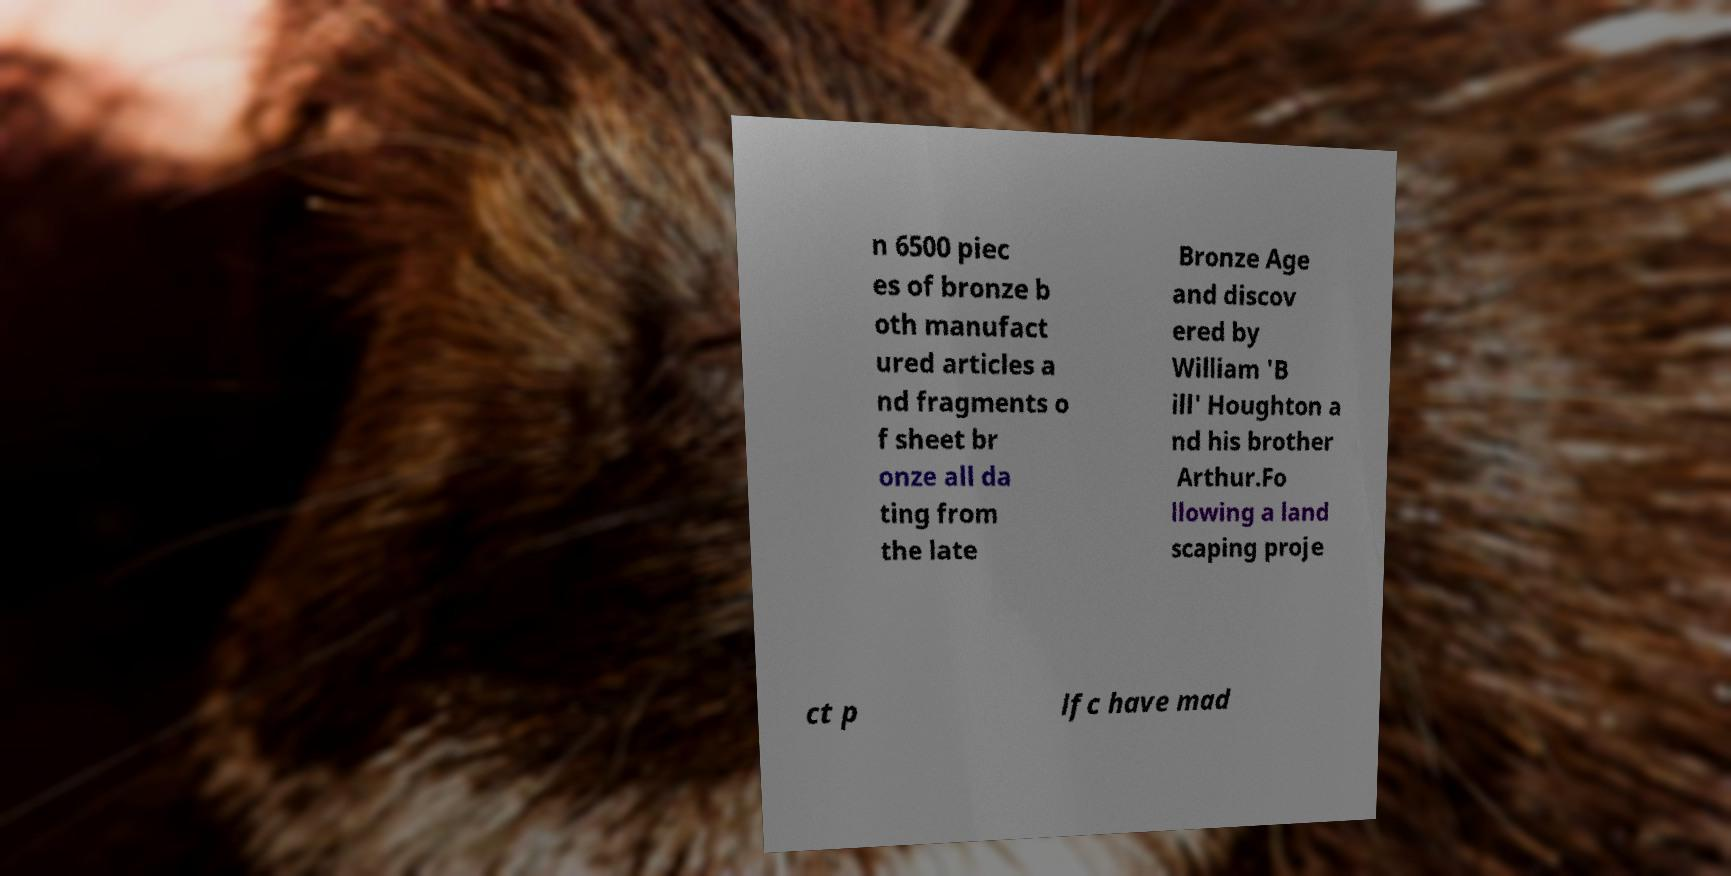Can you read and provide the text displayed in the image?This photo seems to have some interesting text. Can you extract and type it out for me? n 6500 piec es of bronze b oth manufact ured articles a nd fragments o f sheet br onze all da ting from the late Bronze Age and discov ered by William 'B ill' Houghton a nd his brother Arthur.Fo llowing a land scaping proje ct p lfc have mad 